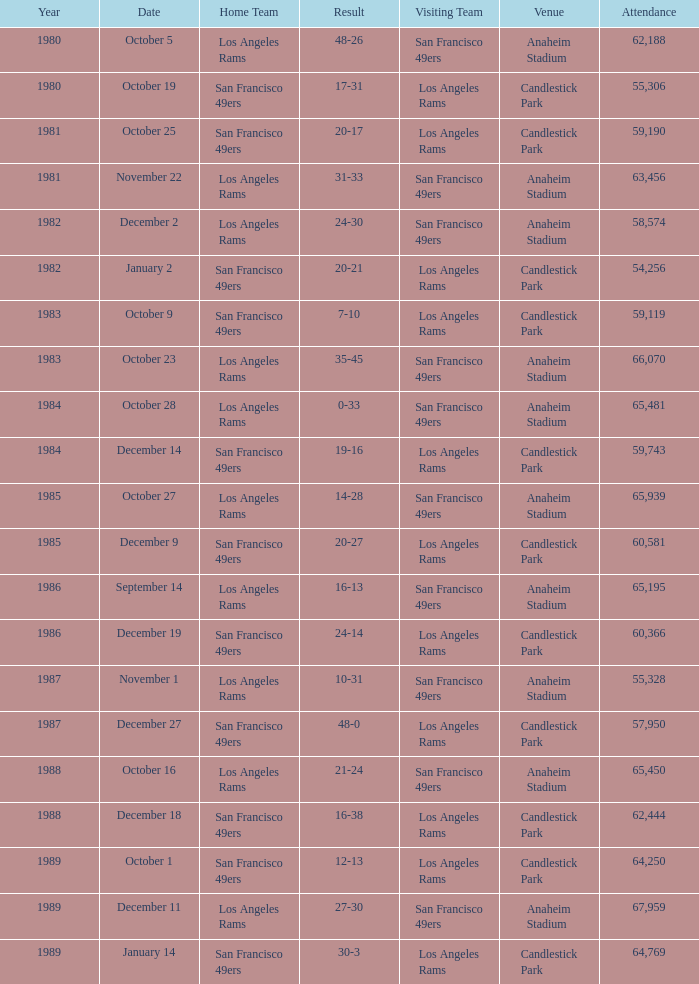What's the total attendance at anaheim stadium after 1983 when the result is 14-28? 1.0. 